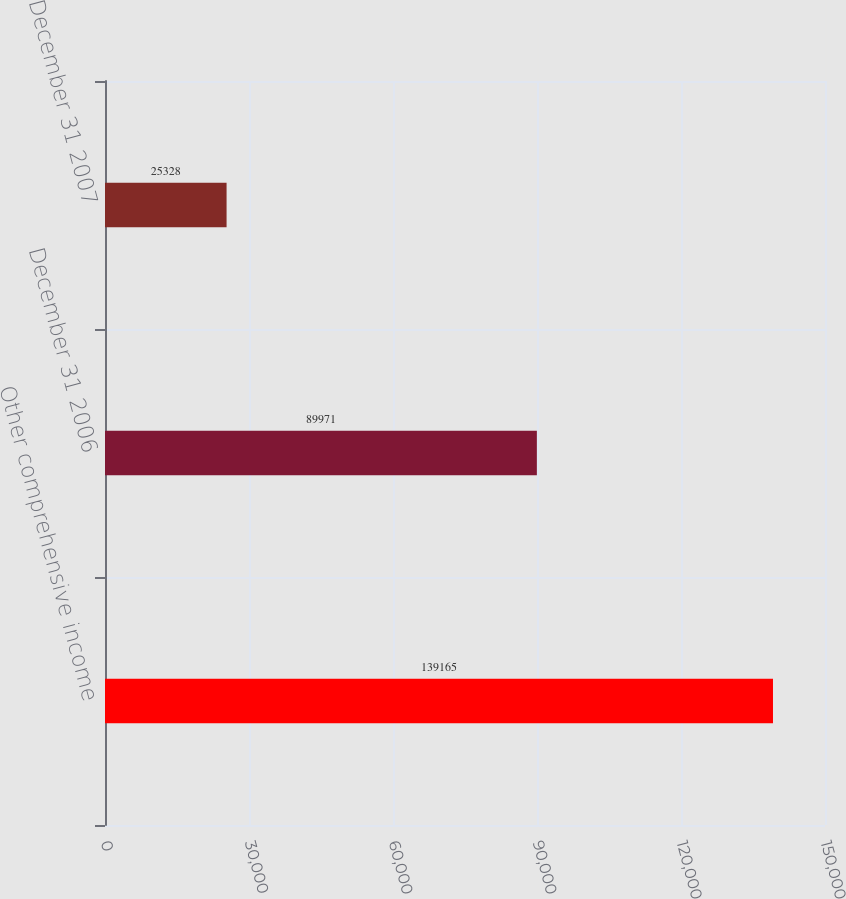Convert chart to OTSL. <chart><loc_0><loc_0><loc_500><loc_500><bar_chart><fcel>Other comprehensive income<fcel>December 31 2006<fcel>December 31 2007<nl><fcel>139165<fcel>89971<fcel>25328<nl></chart> 